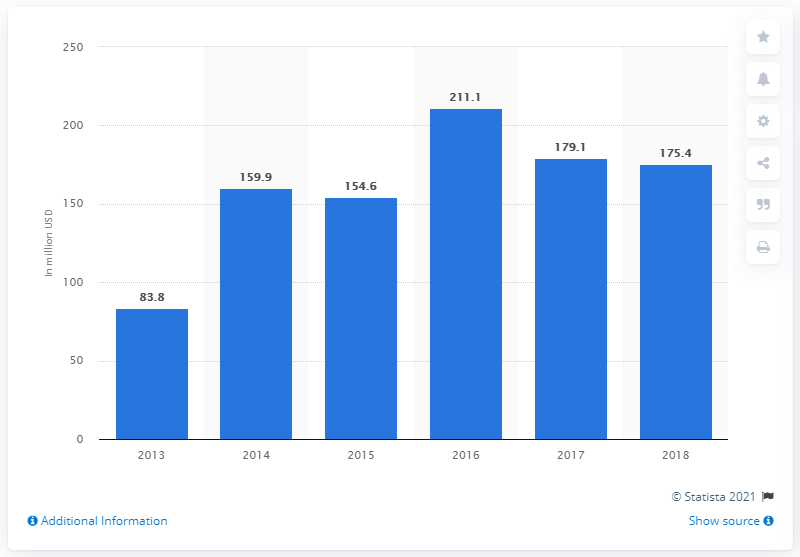Point out several critical features in this image. In 2018, the total transaction value of reward-based crowdfunding in the United States was approximately $175.4 million. 